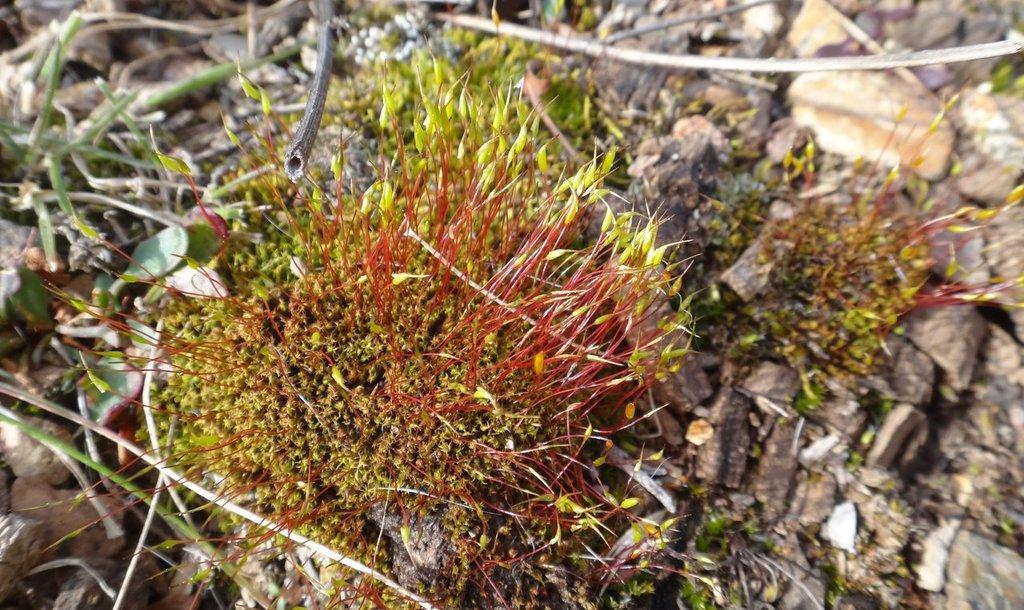How would you summarize this image in a sentence or two? In the image we can see grass and stones. 